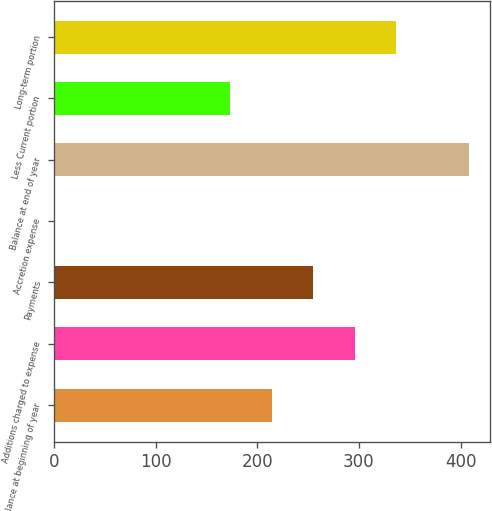Convert chart. <chart><loc_0><loc_0><loc_500><loc_500><bar_chart><fcel>Balance at beginning of year<fcel>Additions charged to expense<fcel>Payments<fcel>Accretion expense<fcel>Balance at end of year<fcel>Less Current portion<fcel>Long-term portion<nl><fcel>214.29<fcel>295.67<fcel>254.98<fcel>1.2<fcel>408.1<fcel>173.6<fcel>336.36<nl></chart> 